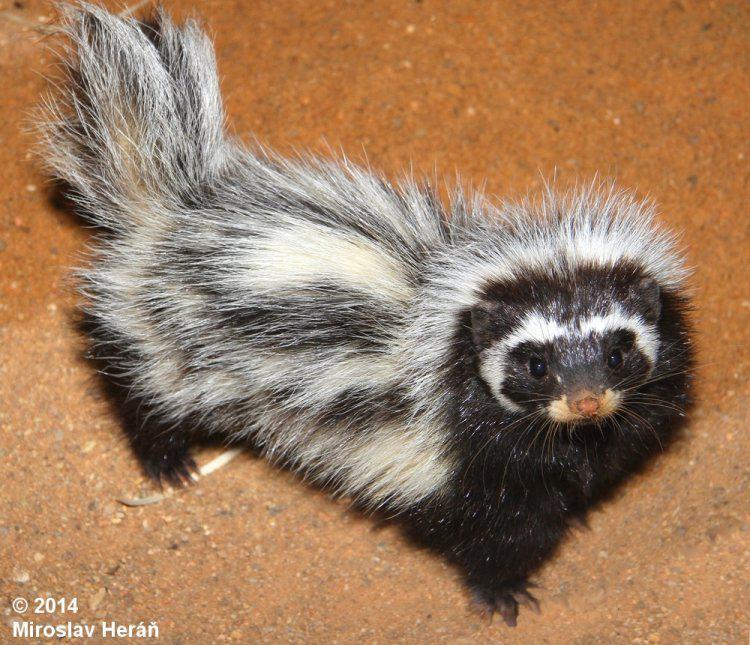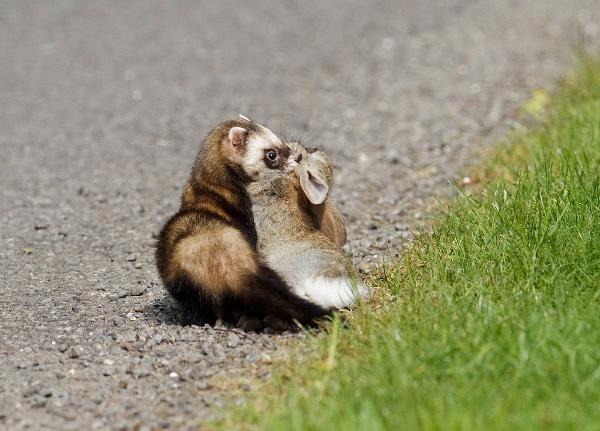The first image is the image on the left, the second image is the image on the right. Given the left and right images, does the statement "The left and right image contains the same number of mustelids facing opposite directions." hold true? Answer yes or no. No. The first image is the image on the left, the second image is the image on the right. Given the left and right images, does the statement "The right image features one ferret with spotted fur and a tail that curves inward over its back, and the left image features an animal with its front paws on a rock and its body turned rightward." hold true? Answer yes or no. No. 